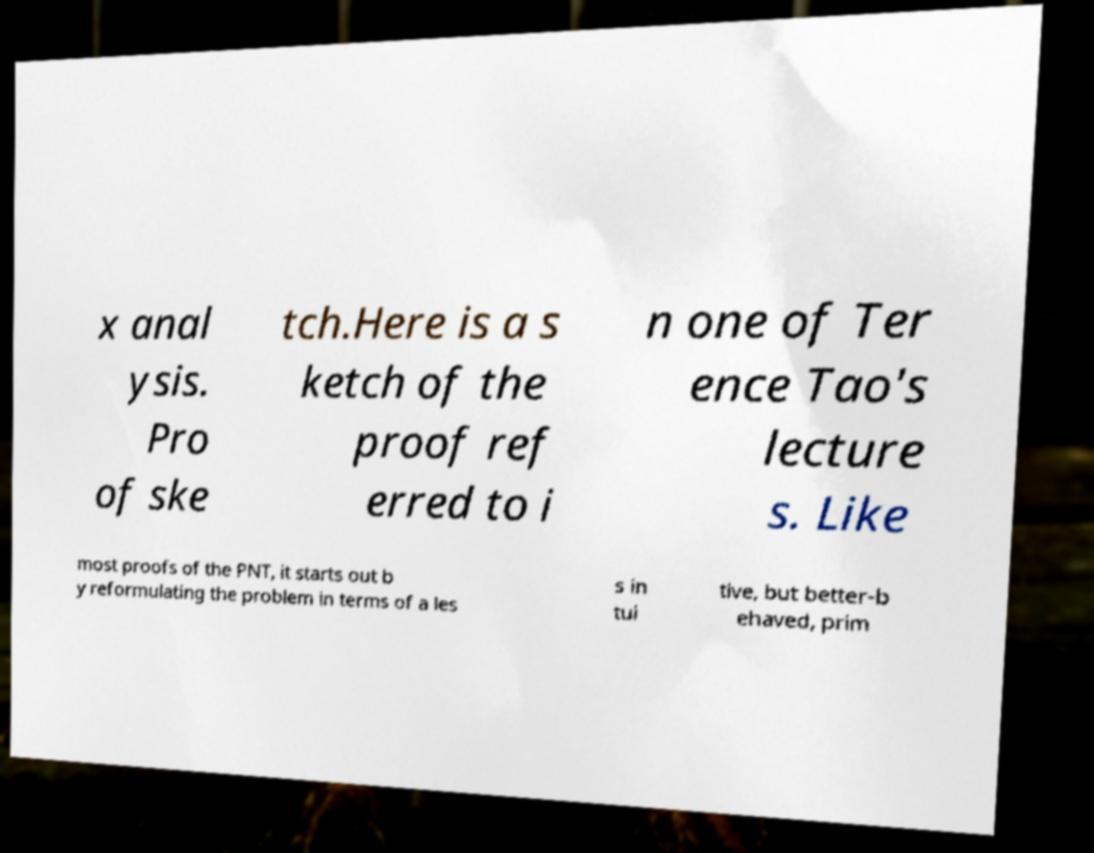Please read and relay the text visible in this image. What does it say? x anal ysis. Pro of ske tch.Here is a s ketch of the proof ref erred to i n one of Ter ence Tao's lecture s. Like most proofs of the PNT, it starts out b y reformulating the problem in terms of a les s in tui tive, but better-b ehaved, prim 